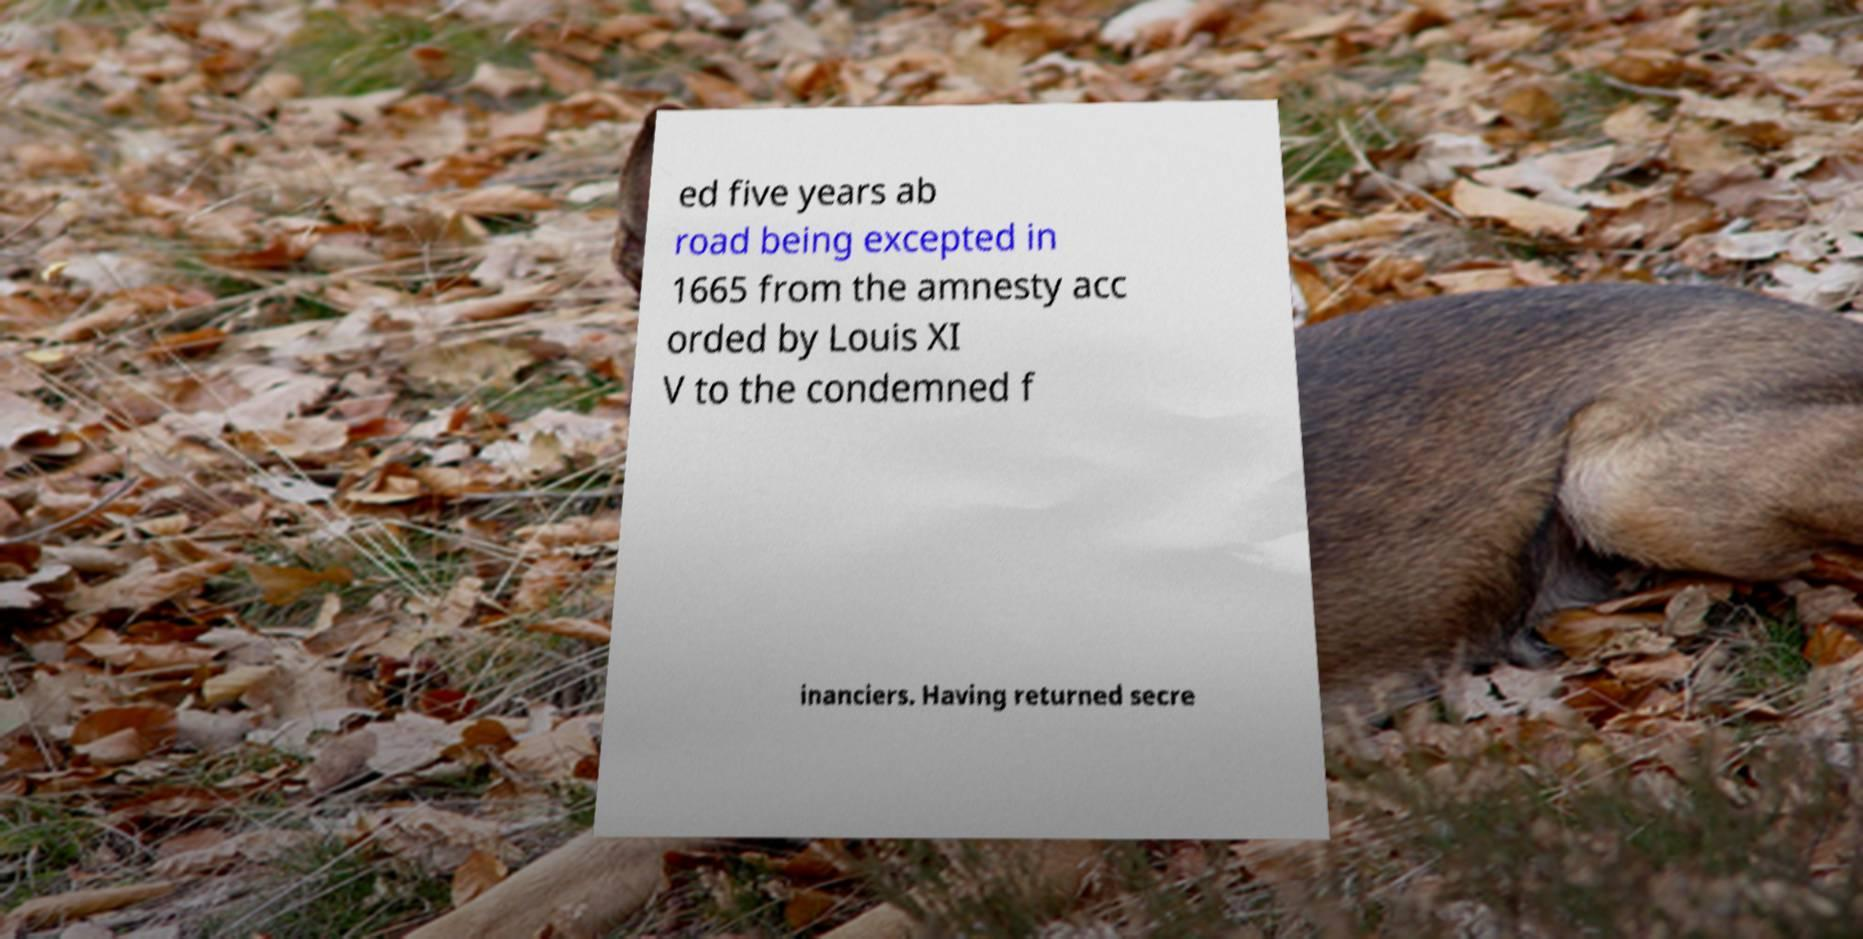I need the written content from this picture converted into text. Can you do that? ed five years ab road being excepted in 1665 from the amnesty acc orded by Louis XI V to the condemned f inanciers. Having returned secre 